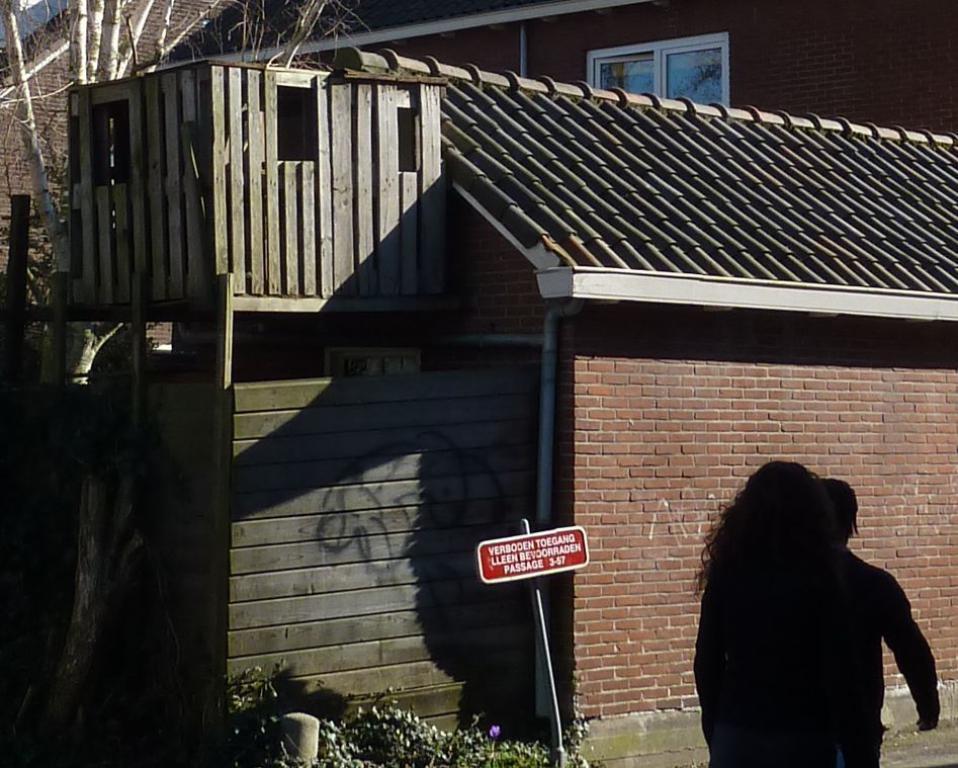Please provide a concise description of this image. On the right side of the image we can see sign board and persons on the road. In the background we can see house and tree. 